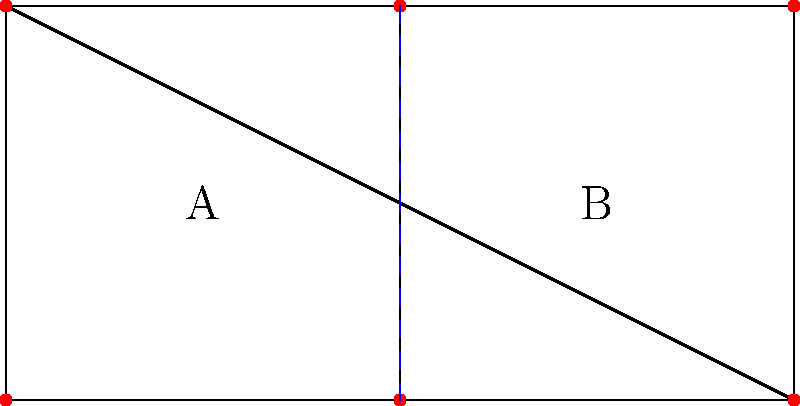In the graph representing a voting district, two potential partitions (A and B) are shown. If each vertex represents a voter and edges represent connections between voters, what graph theory concept is most relevant for ensuring fair representation in this partitioning scheme? To answer this question, let's analyze the graph and its relevance to voting district partitioning:

1. The graph shows 6 vertices (voters) connected by edges, divided into two districts (A and B).

2. In the context of voting districts, we want to ensure fair representation. This means each district should have a similar number of voters and be contiguous.

3. The key graph theory concept relevant here is "graph partitioning." Specifically, we're looking at:

   a) Balanced partitioning: Each partition (district) should have an equal or near-equal number of vertices (voters).
   b) Connectivity: Each partition should form a connected subgraph.

4. In this case, we see that:
   - District A has 3 voters (vertices)
   - District B has 3 voters (vertices)
   - Both districts are connected subgraphs

5. This balanced and connected partitioning helps prevent gerrymandering, where districts are drawn to favor one political group over another.

6. The most relevant graph theory concept here is "balanced graph partitioning," which aims to divide a graph into subgraphs of equal size while minimizing the number of edges between partitions.

Therefore, the most relevant graph theory concept for ensuring fair representation in this partitioning scheme is balanced graph partitioning.
Answer: Balanced graph partitioning 